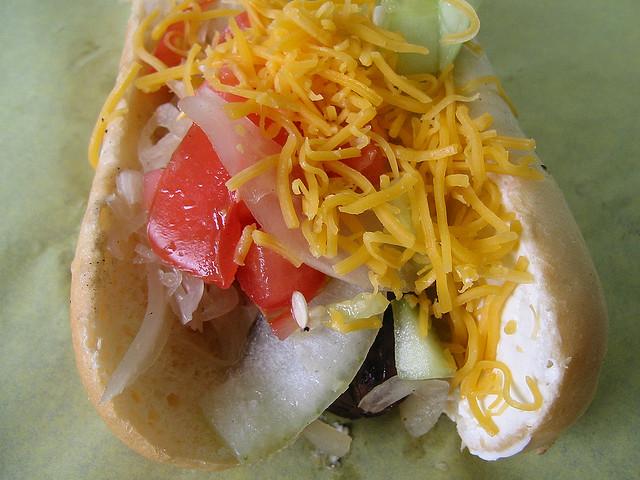What is the red thing in the sandwich?
Write a very short answer. Tomato. Could this be a taco?
Write a very short answer. No. What is the sandwich on?
Keep it brief. Hot dog bun. Is there any cheese?
Write a very short answer. Yes. What vegetables are on this sandwich?
Quick response, please. Tomato. 